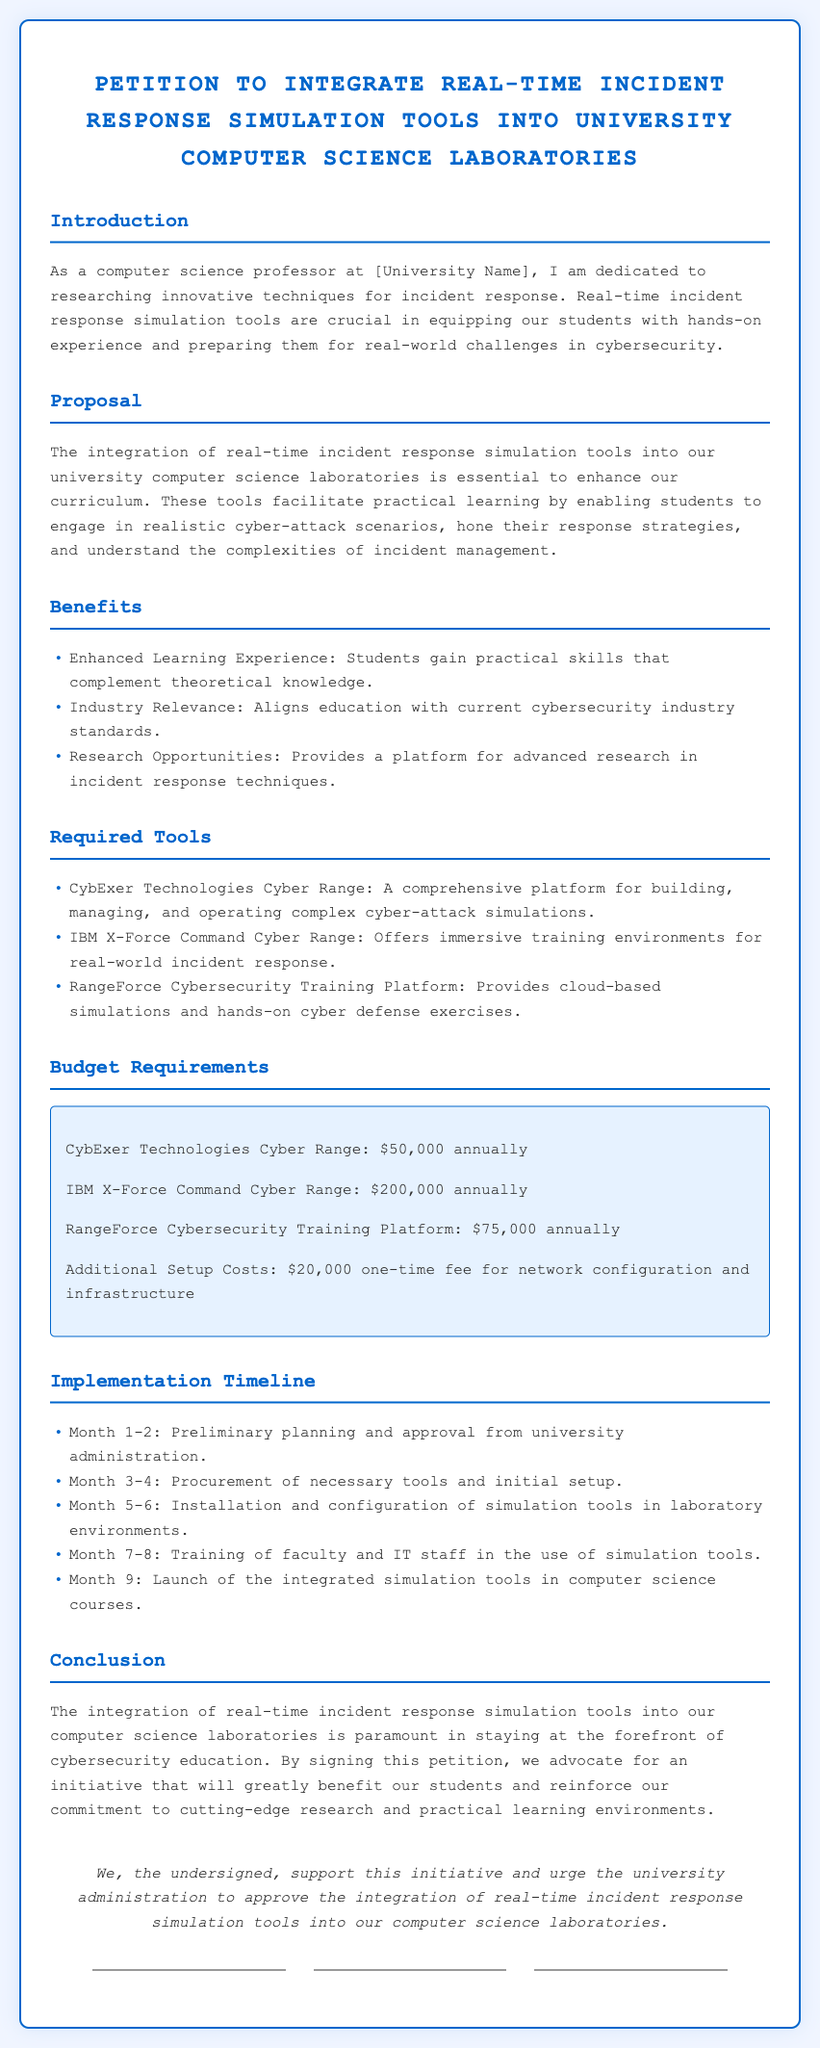What is the title of the petition? The title of the petition is stated at the top of the document and emphasizes the main initiative being proposed.
Answer: Petition to Integrate Real-Time Incident Response Simulation Tools into University Computer Science Laboratories What is the annual cost for CybExer Technologies Cyber Range? The budget requirements section lists annual costs for each tool, specifically noting the amount for CybExer Technologies Cyber Range.
Answer: $50,000 How many months are allocated for training faculty and IT staff? The implementation timeline outlines the preparation that happens after the installation and configuration of the simulation tools.
Answer: 2 months What is one of the proposed tools for simulation? The required tools section lists specific simulation tools included in the proposal for integration.
Answer: CybExer Technologies Cyber Range What is the total one-time setup cost? The budget section includes a one-time fee indicated for additional setup costs mentioned directly following the annual costs.
Answer: $20,000 What is the proposed launch month for the integrated simulation tools? The timeline includes a specific month when the tools are scheduled to be launched in computer science courses as part of the implementation plan.
Answer: Month 9 What does the petition advocate for? The conclusion expresses the main initiative being advocated within the petition, emphasizing its importance for students.
Answer: Integration of real-time incident response simulation tools How many tools are listed under Required Tools? The section on required tools outlines the different simulation platforms that are proposed for integration, which involves careful examination.
Answer: 3 tools 